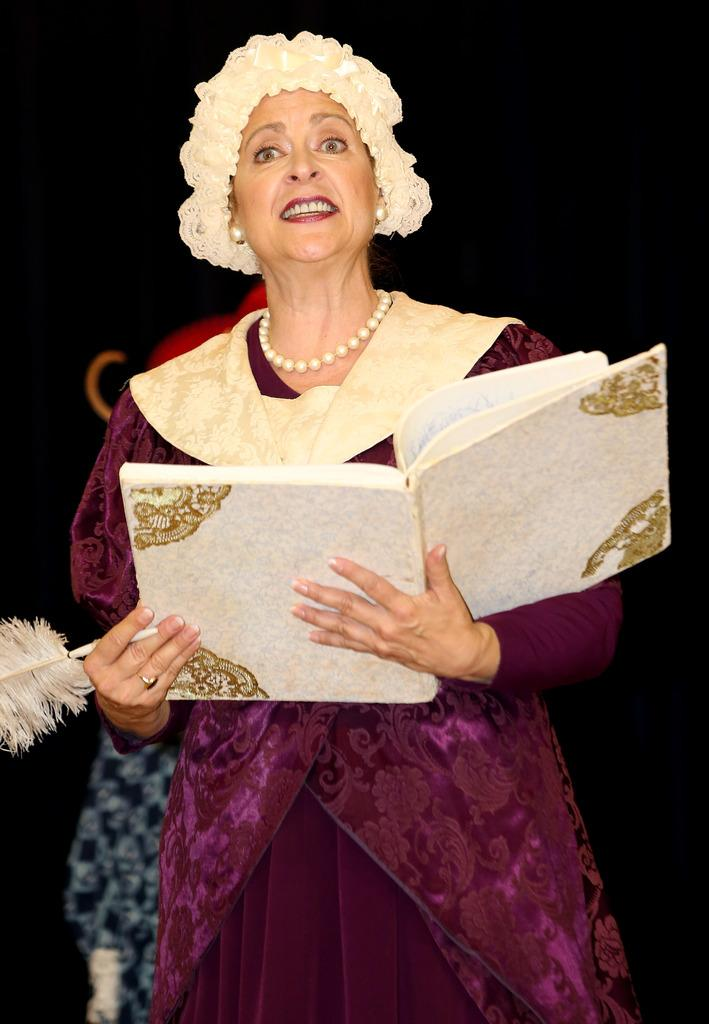What is the main subject of the image? There is a lady person in the image. Can you describe the lady person's attire? The lady person is wearing a pink and gold color dress. What is the lady person holding in her hands? The lady person is holding a book and a pen in her hands. What type of jewelry is the lady person wearing? The lady person is wearing a necklace of pearls. How would you describe the background of the image? The background of the image is dark. Where is the sofa located in the image? There is no sofa present in the image. What type of exchange is taking place between the lady person and the balloon? There is no balloon present in the image, and therefore no exchange can be observed. 